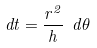Convert formula to latex. <formula><loc_0><loc_0><loc_500><loc_500>d t = { \frac { r ^ { 2 } } { h } } \ d \theta</formula> 